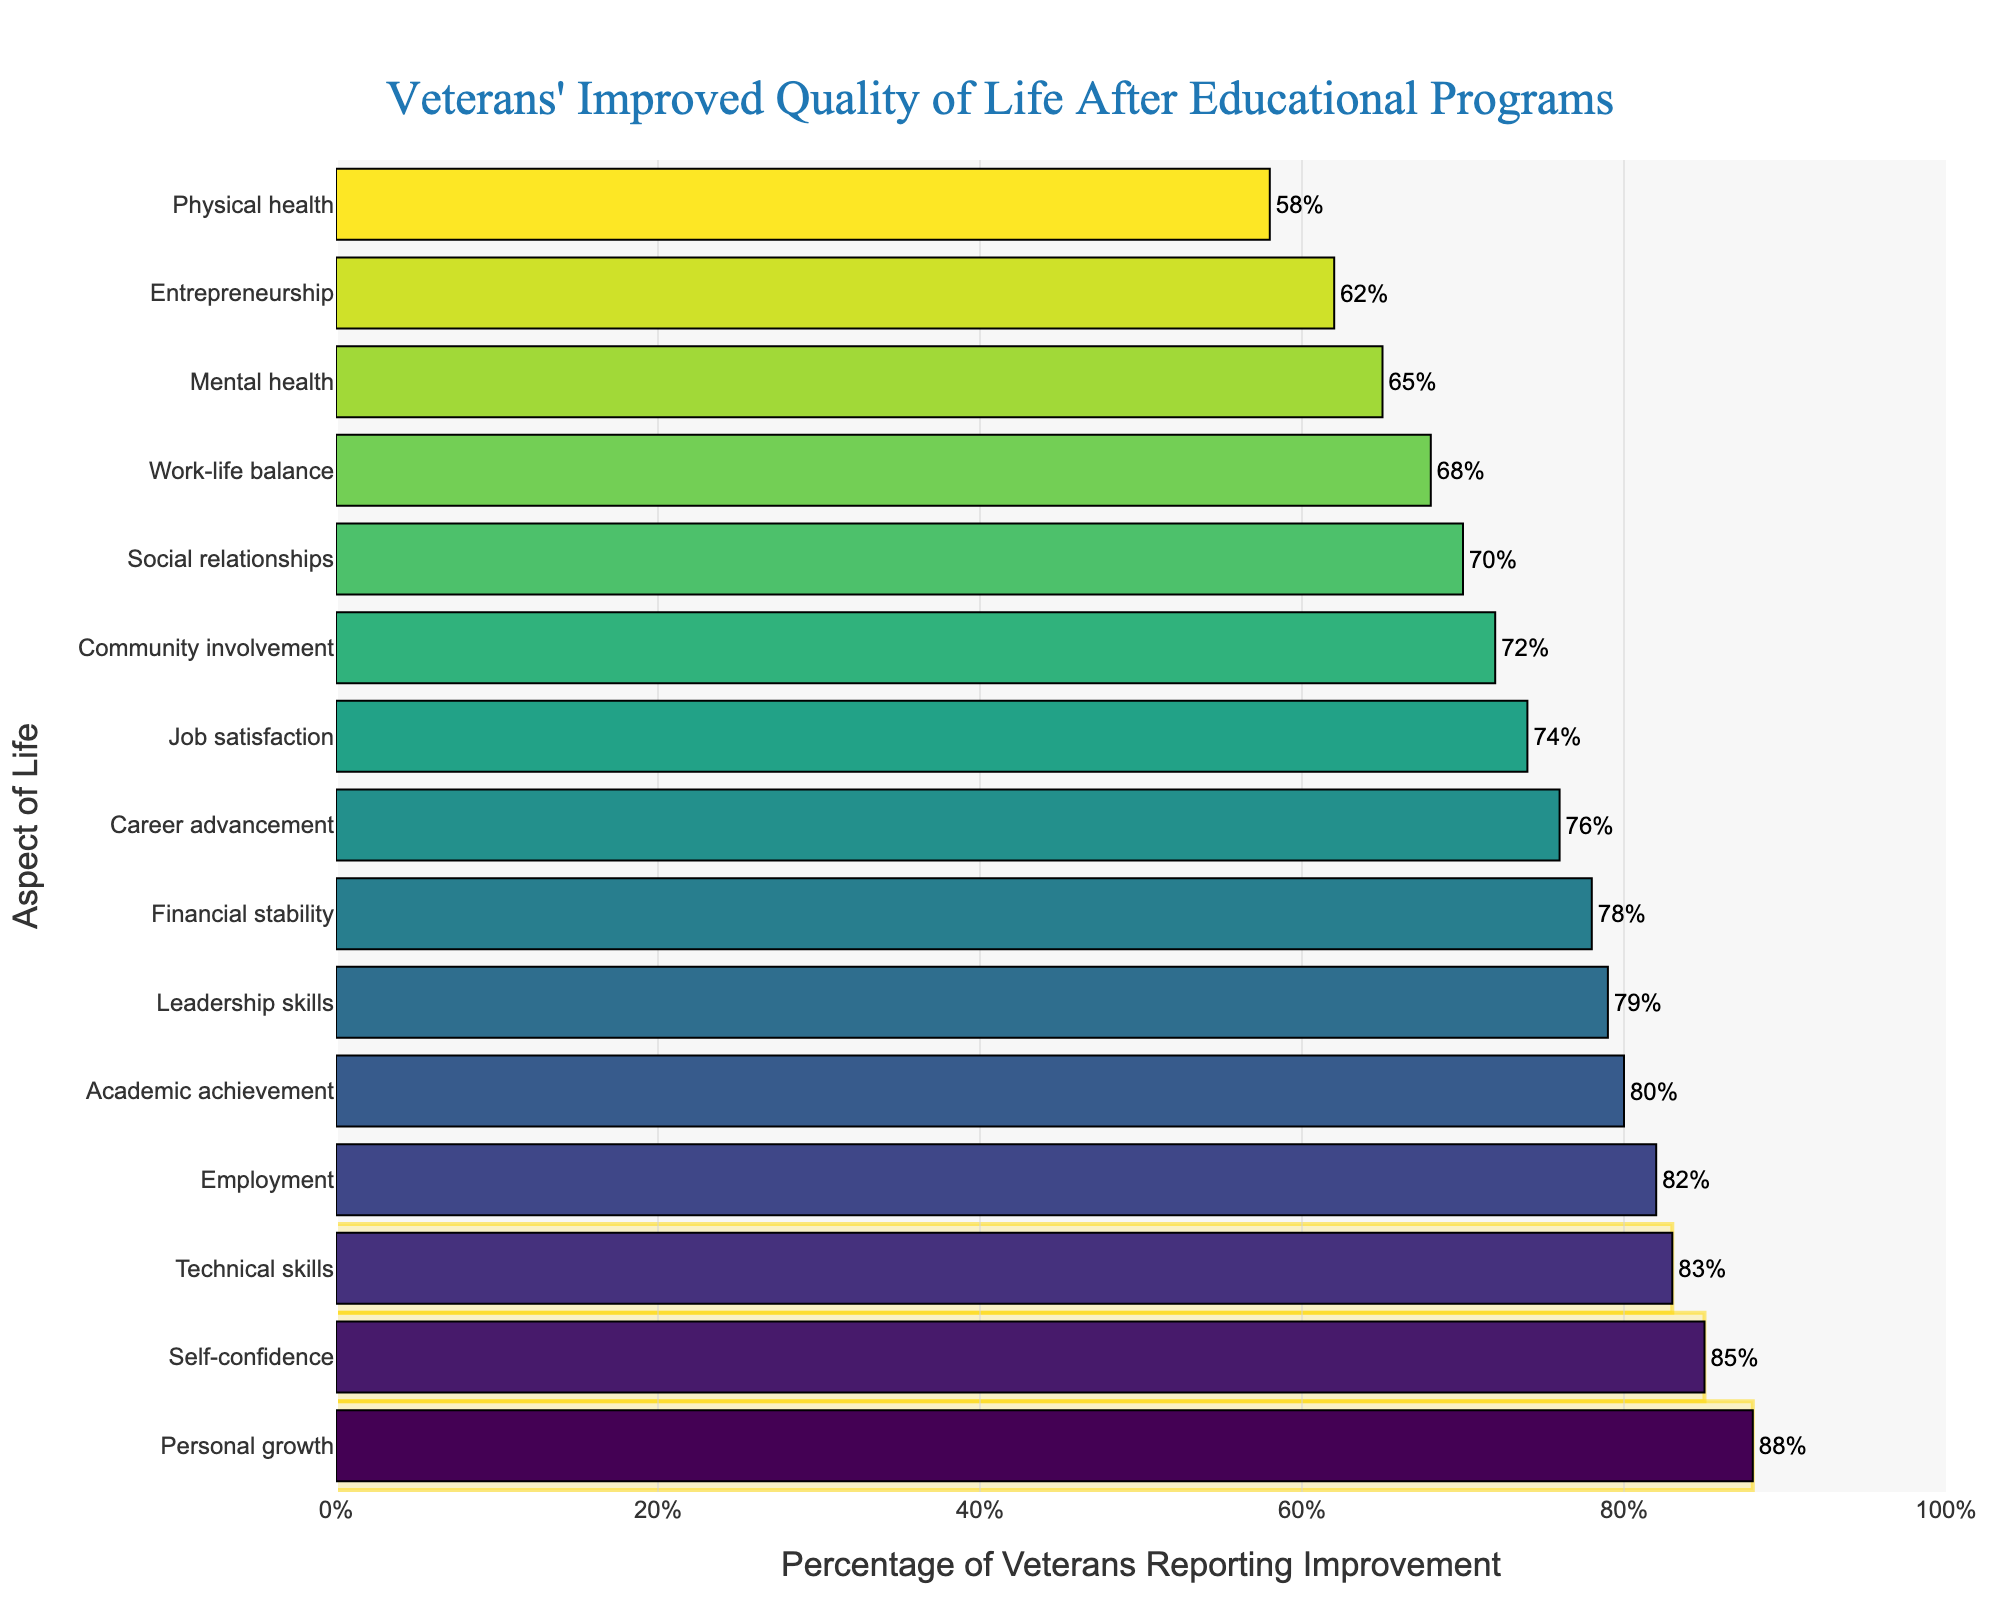What is the percentage of veterans who reported improved employment after completing the educational programs? The bar for the "Employment" aspect shows a percentage value. By looking at the chart, we can see that the percentage for employment is indicated as 82%.
Answer: 82% Which aspect of life had the highest percentage of veterans reporting improvement? Examine the bars to find the tallest one since it represents the highest percentage. The tallest bar corresponds to "Personal growth," which has a percentage value of 88%.
Answer: Personal growth How much greater is the percentage of veterans reporting an improvement in self-confidence compared to mental health? Find the percentages for both "Self-confidence" and "Mental health" and subtract the latter from the former (85% - 65%).
Answer: 20% Which aspects of life are highlighted in the top 3 improvements in the chart? Look for the bars highlighted with a rectangle and list their aspects: "Personal growth," "Self-confidence," and "Technical skills."
Answer: Personal growth, Self-confidence, Technical skills What is the range of percentages reported for improved quality of life aspects? The range is obtained by subtracting the smallest percentage from the largest (88% for Personal growth - 58% for Physical health).
Answer: 30% What is the average percentage of veterans reporting improvement for the aspects highlighted in yellow? The highlighted aspects are "Personal growth" (88%), "Self-confidence" (85%), and "Technical skills" (83%). The average is (88 + 85 + 83)/3.
Answer: 85.33% What percentage of veterans reported improved academic achievement, and how does it compare to physical health? Locate the bars for "Academic achievement" and "Physical health." Academic achievement is 80%, and Physical health is 58%. The comparison shows academic achievement is higher.
Answer: 22% higher Which two aspects have the closest improvement percentages, and what are those percentages? Look for bars with nearly identical endings. "Financial stability" and "Leadership skills" both are within 1% of each other (78% and 79%).
Answer: Financial stability (78%), Leadership skills (79%) How many aspects reported improvements of 70% or higher? Count the bars that have a percentage value of 70% or more: Employment, Financial stability, Social relationships, Self-confidence, Career advancement, Academic achievement, Community involvement, Leadership skills, Technical skills, Job satisfaction.
Answer: 10 